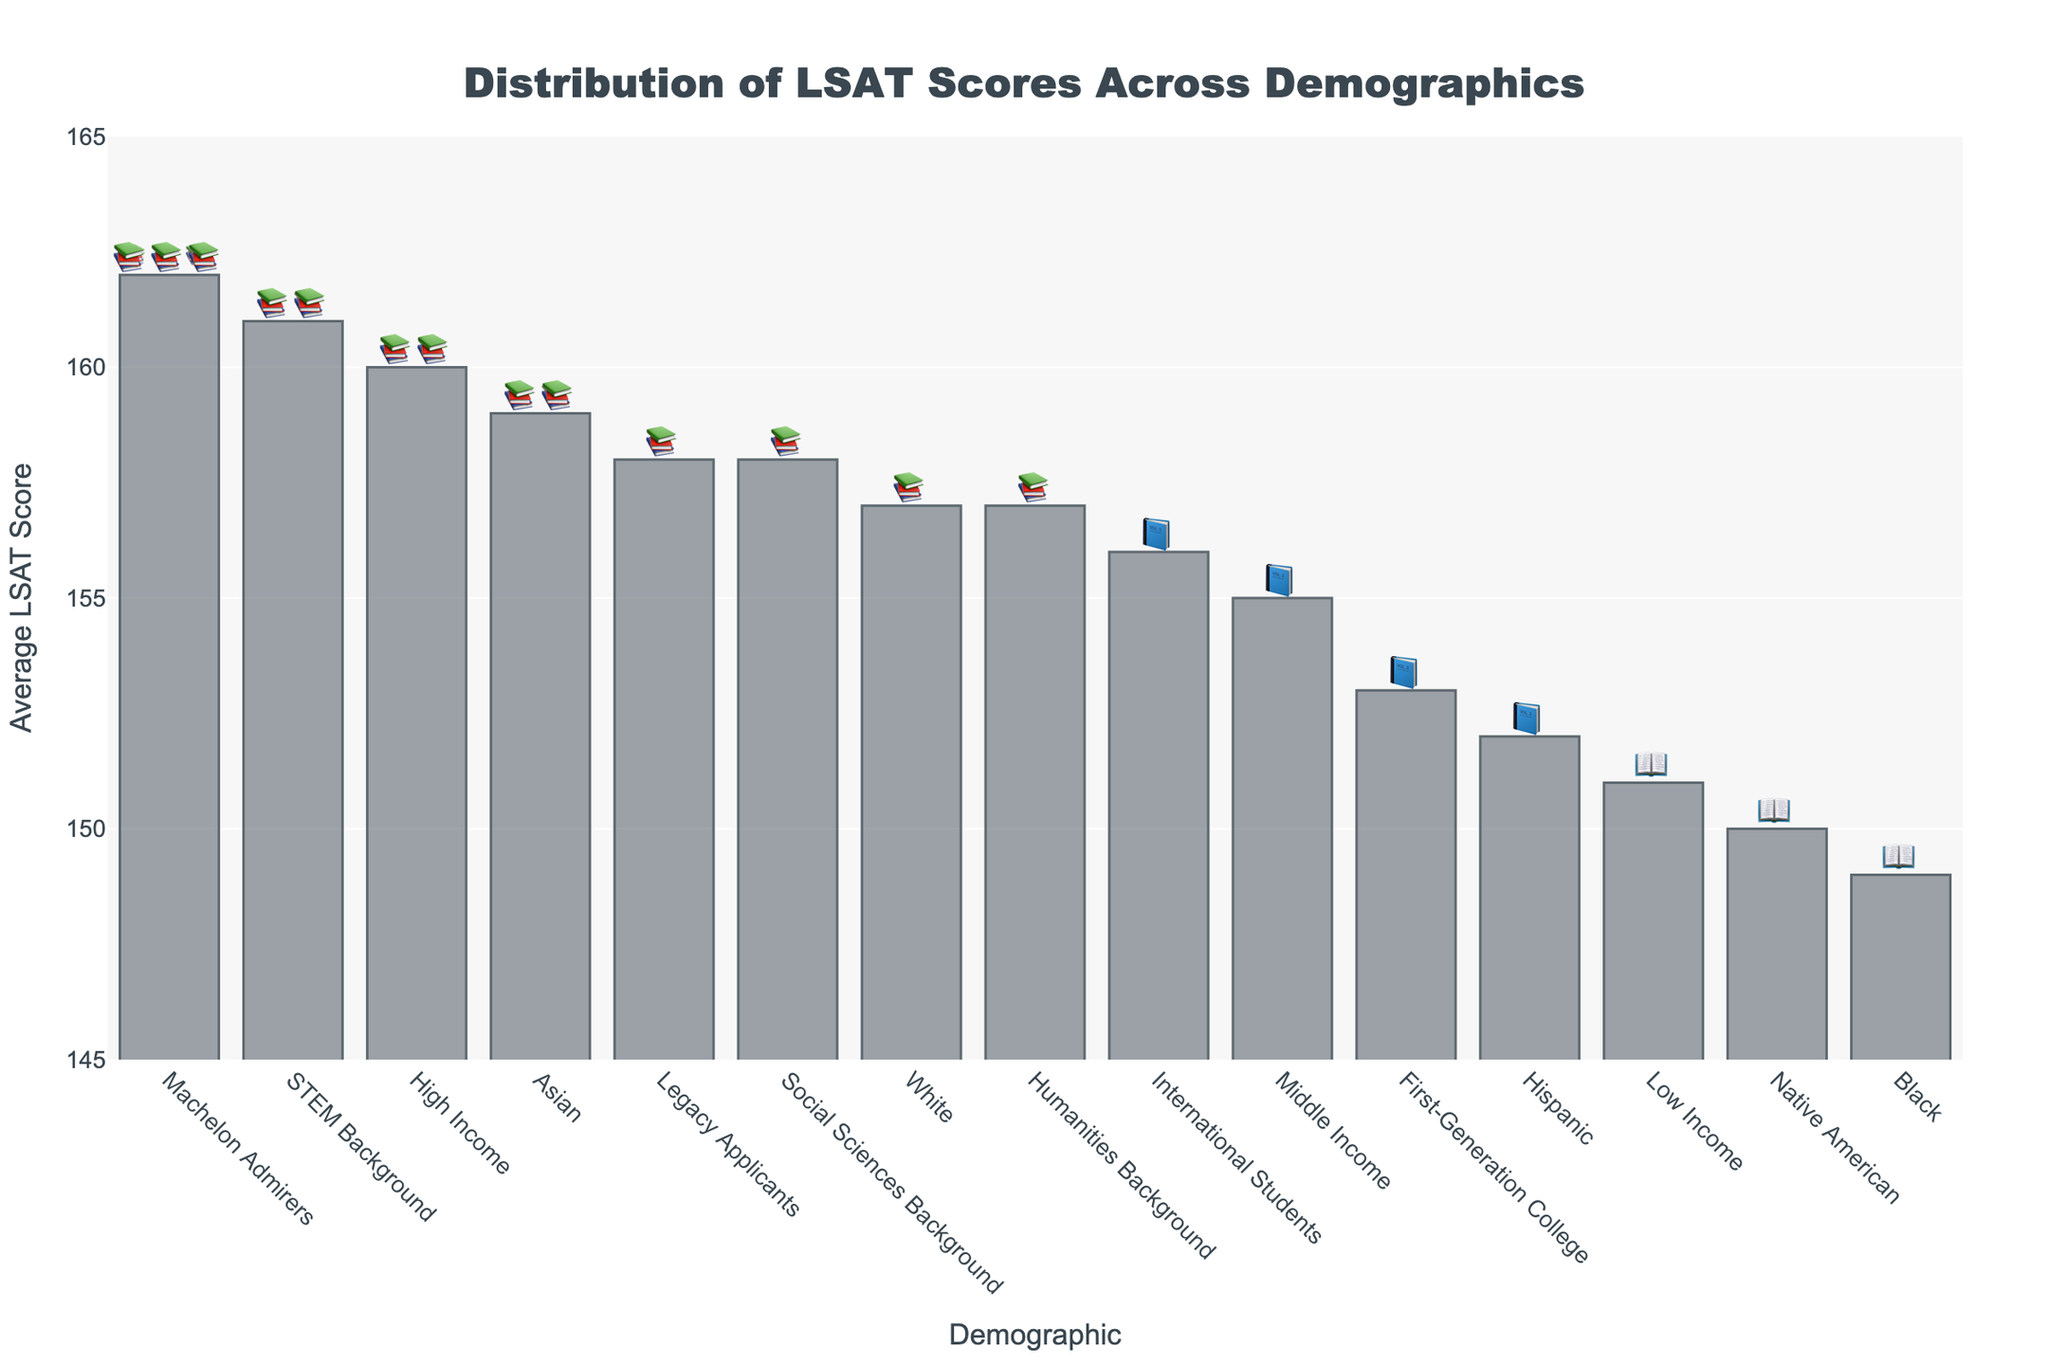Which demographic has the highest average LSAT score? The demographic with the highest average LSAT score can be found by identifying the tallest bar in the chart. "Machelon Admirers" has the highest bar with an average score of 162.
Answer: Machelon Admirers Which demographic group scored lowest in average LSAT scores? To find the lowest average LSAT score, locate the shortest bar in the chart. The "Black" demographic has the shortest bar with an average LSAT score of 149.
Answer: Black What is the difference in average LSAT score between "Low Income" and "High Income" demographics? Find the average LSAT scores for "Low Income" and "High Income" and subtract the smaller from the larger. The scores are 151 for "Low Income" and 160 for "High Income". The difference is 160 - 151 = 9.
Answer: 9 How many demographic groups have average LSAT scores of 158 or higher? Identify and count the bars that reach or exceed the height corresponding to a score of 158. The groups are "High Income", "Legacy Applicants", "Social Sciences Background", "Humanities Background", "Asian", "Machelon Admirers", and "STEM Background", totaling 7 groups.
Answer: 7 Which demographic has the emoji grade "📚"? Locate the emoji grade "📚" in the chart annotations and identify the associated demographic. "White" is one such demographic.
Answer: White Which two demographics have an average LSAT score of 158? Identify the bars that reach the height corresponding to a score of 158. The demographics are "Legacy Applicants" and "Social Sciences Background".
Answer: Legacy Applicants, Social Sciences Background Do "First-Generation College" students have a higher or lower average LSAT score than "Middle Income" students? Compare the average LSAT scores of "First-Generation College" (153) and "Middle Income" (155). "First-Generation College" has a lower score than "Middle Income".
Answer: Lower What is the average LSAT score for "International Students"? Identify the bar for "International Students" and read its corresponding value on the y-axis. The average LSAT score is 156.
Answer: 156 How many "📖" emoji grades are there, and which demographics have them? Count the occurrences of the "📖" emoji and list the demographics. They are "Black", "Native American", and "Low Income", totaling 3 demographics.
Answer: 3; Black, Native American, Low Income 